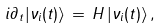<formula> <loc_0><loc_0><loc_500><loc_500>i \partial _ { t } | \nu _ { i } ( t ) \rangle \, = \, H \, | \nu _ { i } ( t ) \rangle \, ,</formula> 